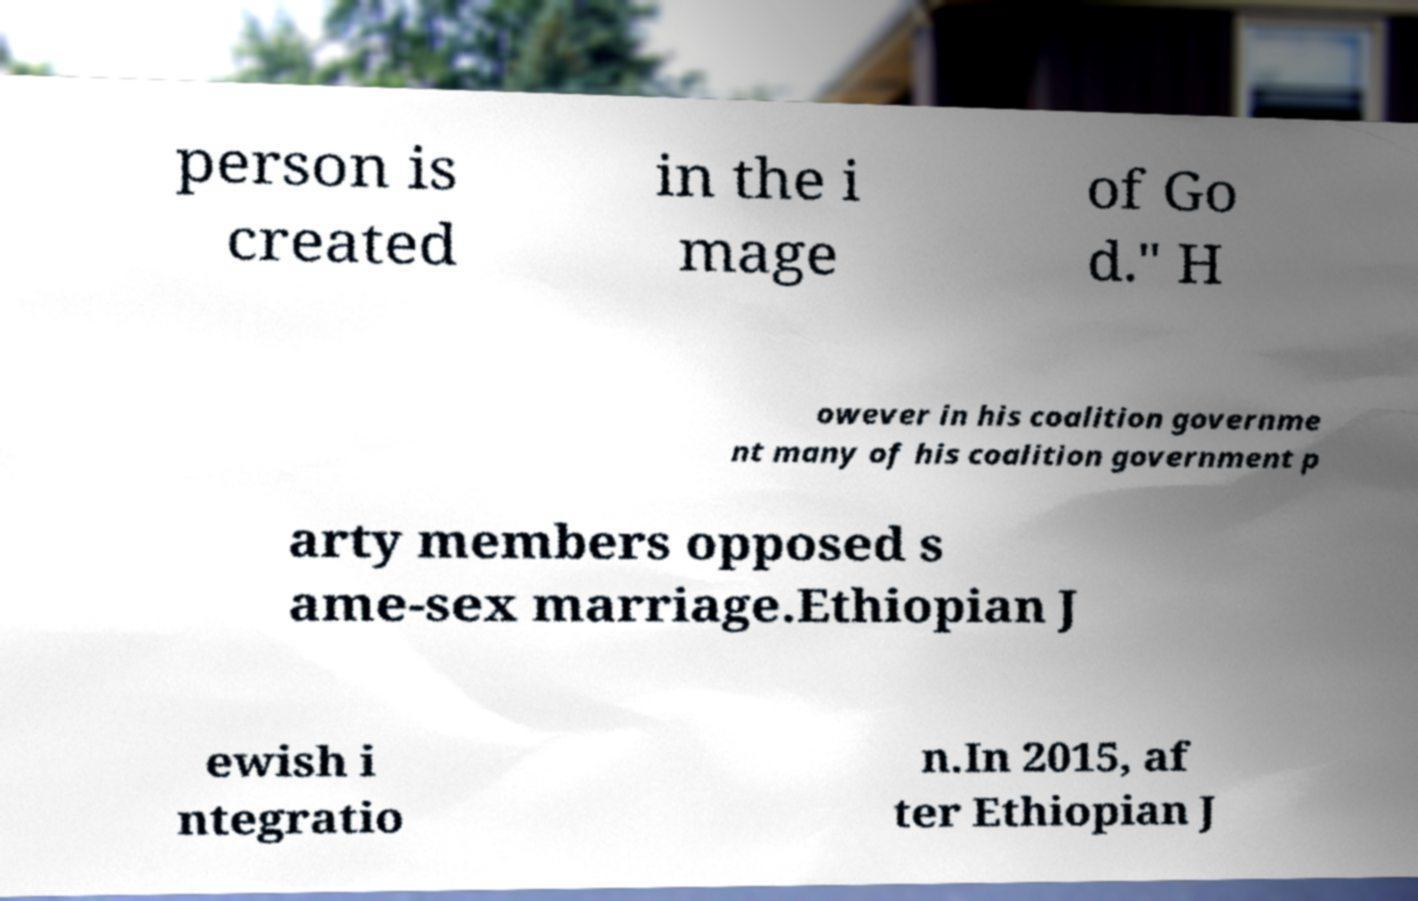Can you read and provide the text displayed in the image?This photo seems to have some interesting text. Can you extract and type it out for me? person is created in the i mage of Go d." H owever in his coalition governme nt many of his coalition government p arty members opposed s ame-sex marriage.Ethiopian J ewish i ntegratio n.In 2015, af ter Ethiopian J 